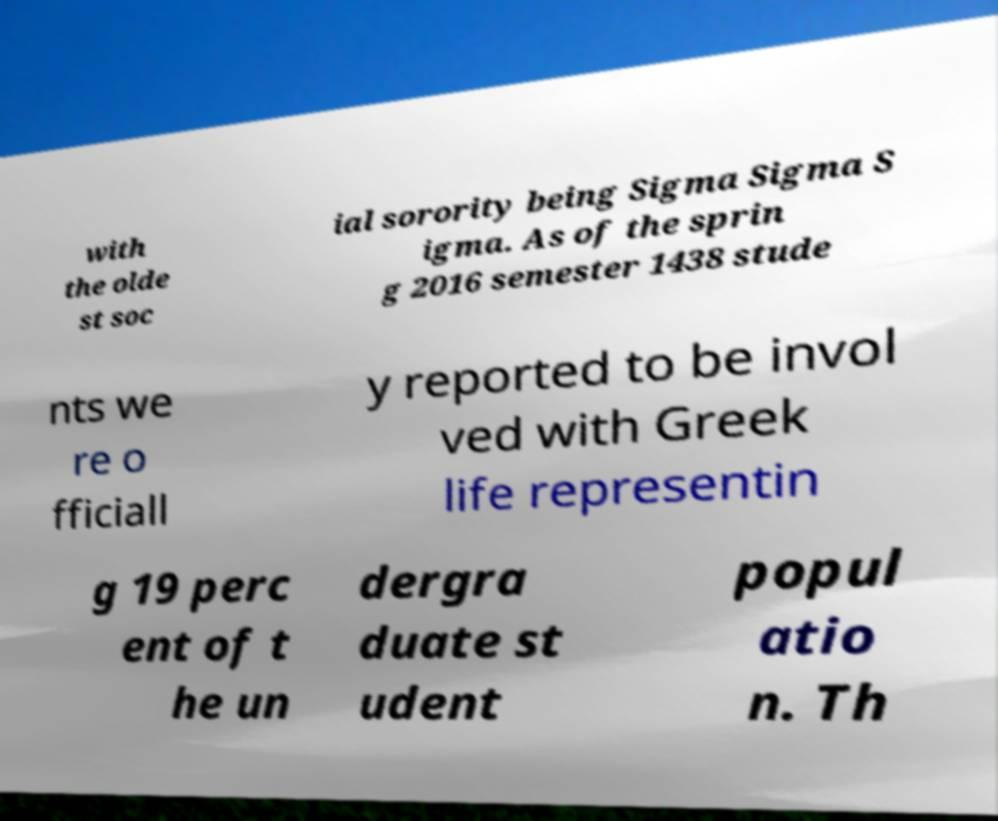Please read and relay the text visible in this image. What does it say? with the olde st soc ial sorority being Sigma Sigma S igma. As of the sprin g 2016 semester 1438 stude nts we re o fficiall y reported to be invol ved with Greek life representin g 19 perc ent of t he un dergra duate st udent popul atio n. Th 